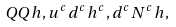Convert formula to latex. <formula><loc_0><loc_0><loc_500><loc_500>Q Q h , u ^ { c } d ^ { c } h ^ { c } , d ^ { c } N ^ { c } h ,</formula> 